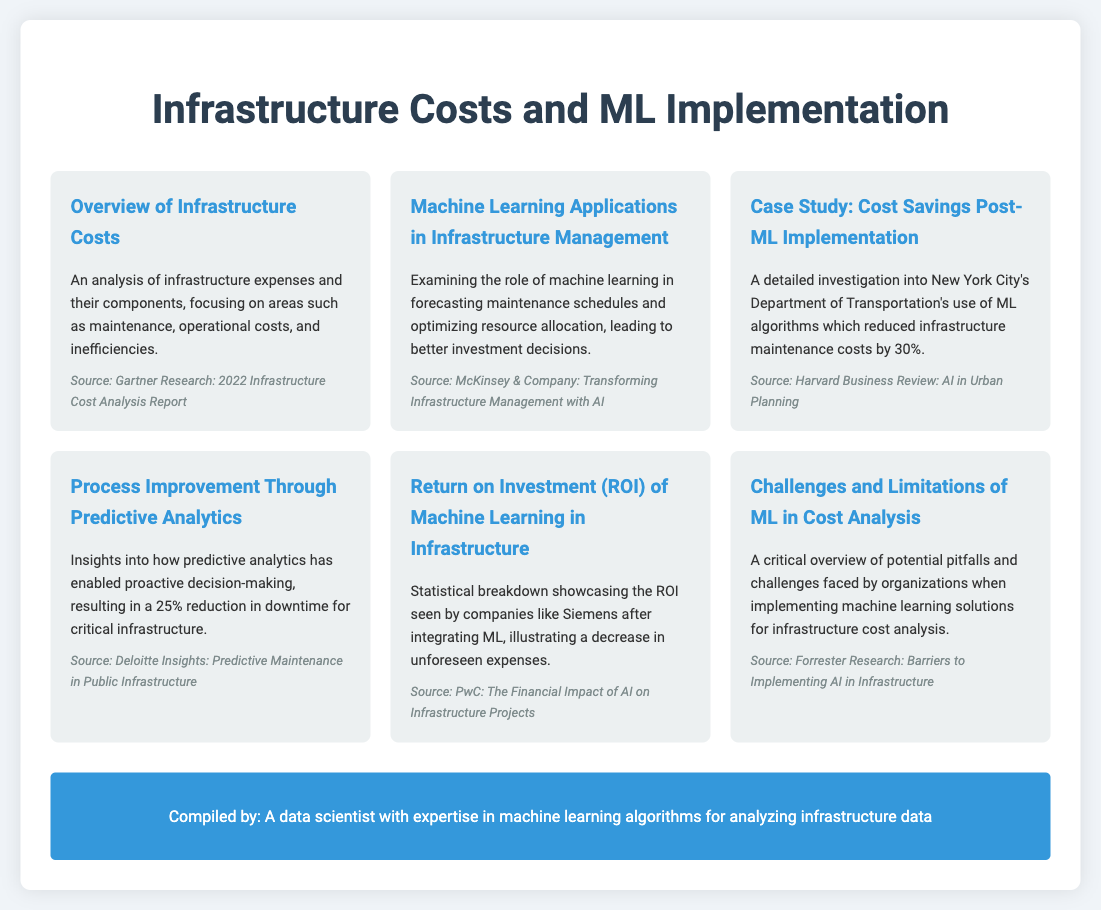What is the percentage reduction in infrastructure maintenance costs reported in the case study? The case study highlights that New York City's Department of Transportation reduced infrastructure maintenance costs by 30% after implementing machine learning.
Answer: 30% What is the source of the data for the overview of infrastructure costs? The document cites Gartner Research's 2022 Infrastructure Cost Analysis Report as the source for the overview of infrastructure costs.
Answer: Gartner Research: 2022 Infrastructure Cost Analysis Report What role does machine learning play in resource allocation? The document indicates that machine learning helps improve forecasting maintenance schedules and optimizes resource allocation.
Answer: Forecasting maintenance schedules and optimizing resource allocation What is the percentage reduction in downtime achieved through predictive analytics? According to the insights provided in the document, predictive analytics has led to a 25% reduction in downtime for critical infrastructure.
Answer: 25% What company is mentioned as having a positive ROI after integrating machine learning? The document references Siemens as a company that witnessed a decrease in unforeseen expenses due to machine learning integration.
Answer: Siemens What is discussed as a potential pitfall of implementing machine learning in cost analysis? The document provides a critical overview of the challenges and limitations organizations may face when adopting machine learning solutions for infrastructure cost analysis.
Answer: Challenges and limitations What is the title of the section discussing the ROI of machine learning? The section discussing the ROI of machine learning is titled "Return on Investment (ROI) of Machine Learning in Infrastructure."
Answer: Return on Investment (ROI) of Machine Learning in Infrastructure What type of improvements does the document relate to predictive analytics? The document states that predictive analytics enables proactive decision-making, which is a significant improvement for processes.
Answer: Proactive decision-making 